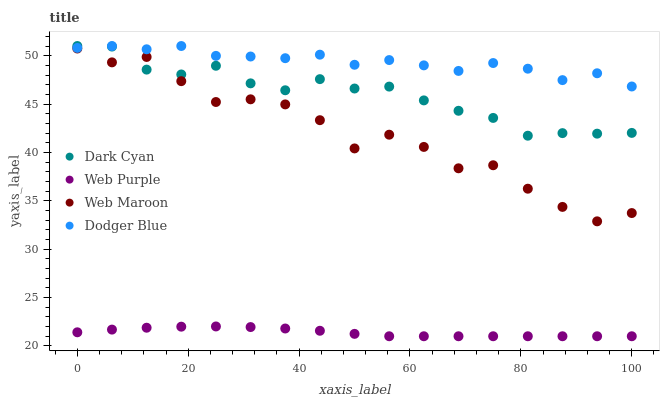Does Web Purple have the minimum area under the curve?
Answer yes or no. Yes. Does Dodger Blue have the maximum area under the curve?
Answer yes or no. Yes. Does Dodger Blue have the minimum area under the curve?
Answer yes or no. No. Does Web Purple have the maximum area under the curve?
Answer yes or no. No. Is Web Purple the smoothest?
Answer yes or no. Yes. Is Web Maroon the roughest?
Answer yes or no. Yes. Is Dodger Blue the smoothest?
Answer yes or no. No. Is Dodger Blue the roughest?
Answer yes or no. No. Does Web Purple have the lowest value?
Answer yes or no. Yes. Does Dodger Blue have the lowest value?
Answer yes or no. No. Does Dodger Blue have the highest value?
Answer yes or no. Yes. Does Web Purple have the highest value?
Answer yes or no. No. Is Web Purple less than Web Maroon?
Answer yes or no. Yes. Is Dark Cyan greater than Web Purple?
Answer yes or no. Yes. Does Web Maroon intersect Dark Cyan?
Answer yes or no. Yes. Is Web Maroon less than Dark Cyan?
Answer yes or no. No. Is Web Maroon greater than Dark Cyan?
Answer yes or no. No. Does Web Purple intersect Web Maroon?
Answer yes or no. No. 